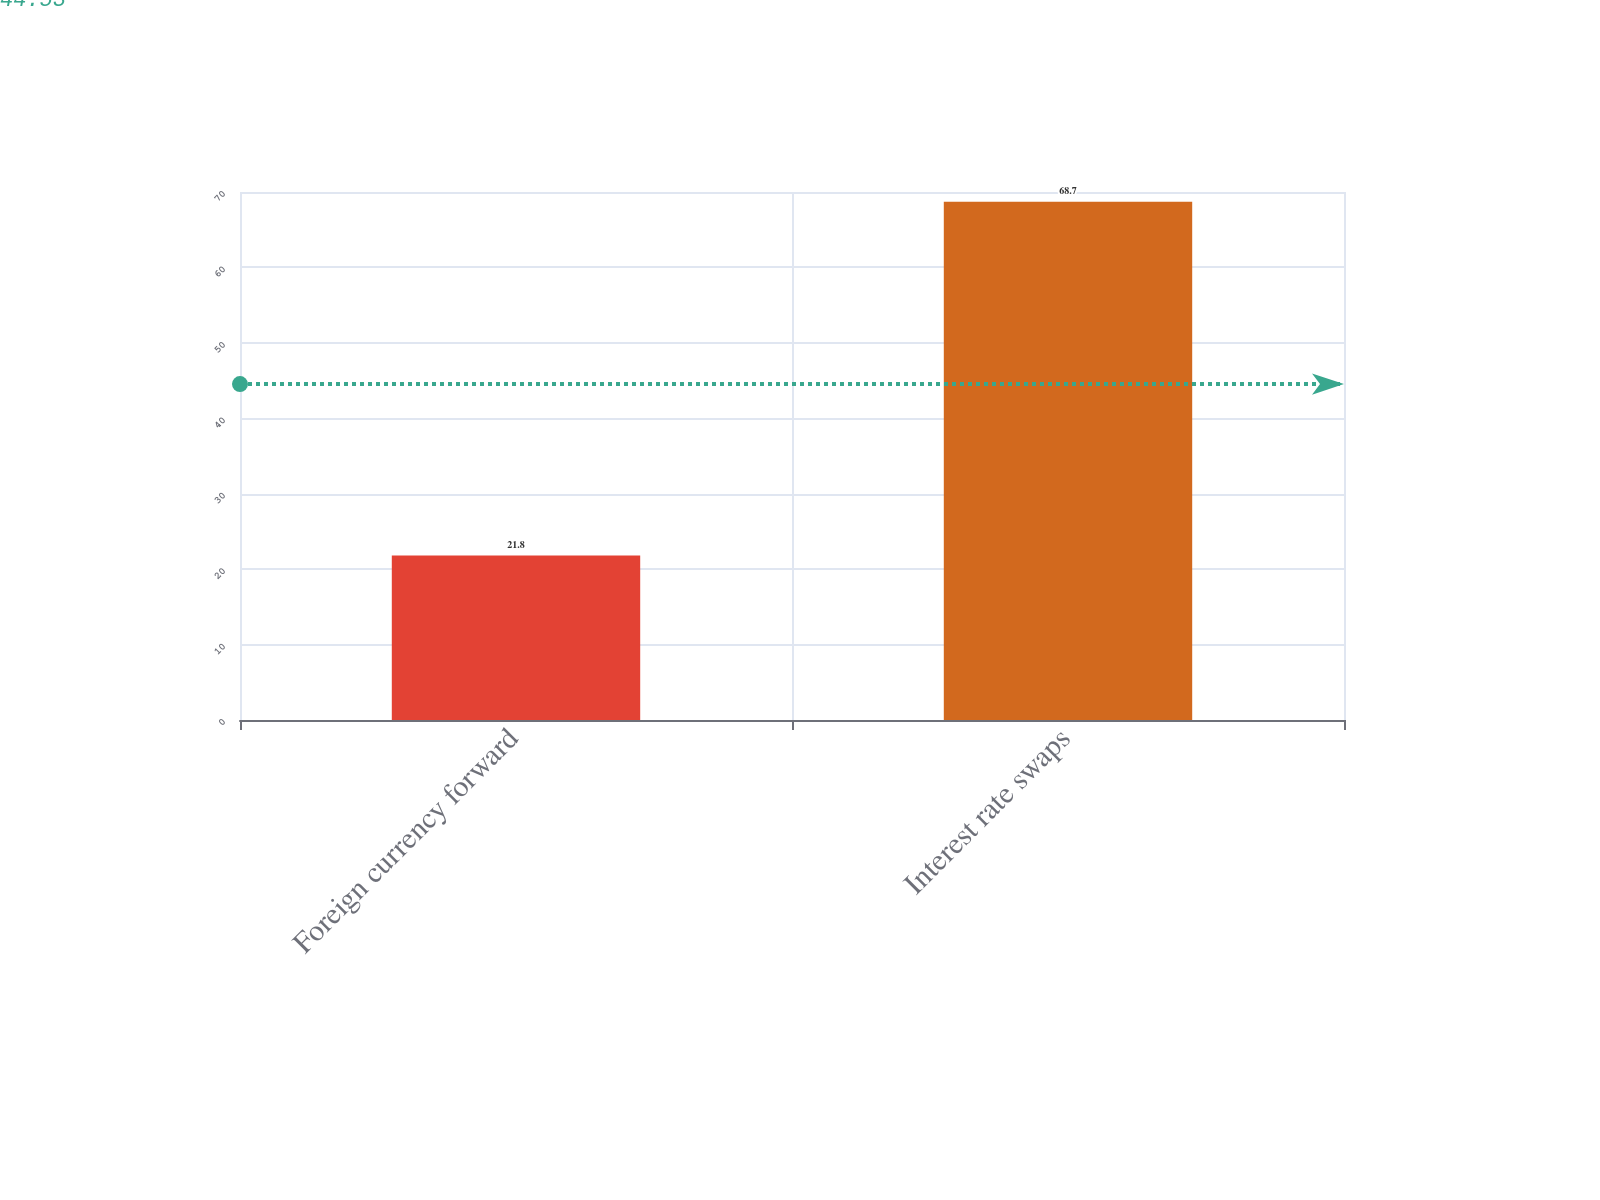Convert chart. <chart><loc_0><loc_0><loc_500><loc_500><bar_chart><fcel>Foreign currency forward<fcel>Interest rate swaps<nl><fcel>21.8<fcel>68.7<nl></chart> 